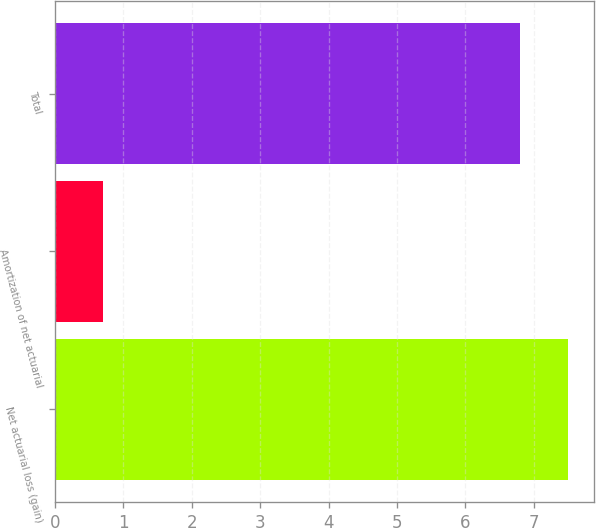Convert chart. <chart><loc_0><loc_0><loc_500><loc_500><bar_chart><fcel>Net actuarial loss (gain)<fcel>Amortization of net actuarial<fcel>Total<nl><fcel>7.5<fcel>0.7<fcel>6.8<nl></chart> 